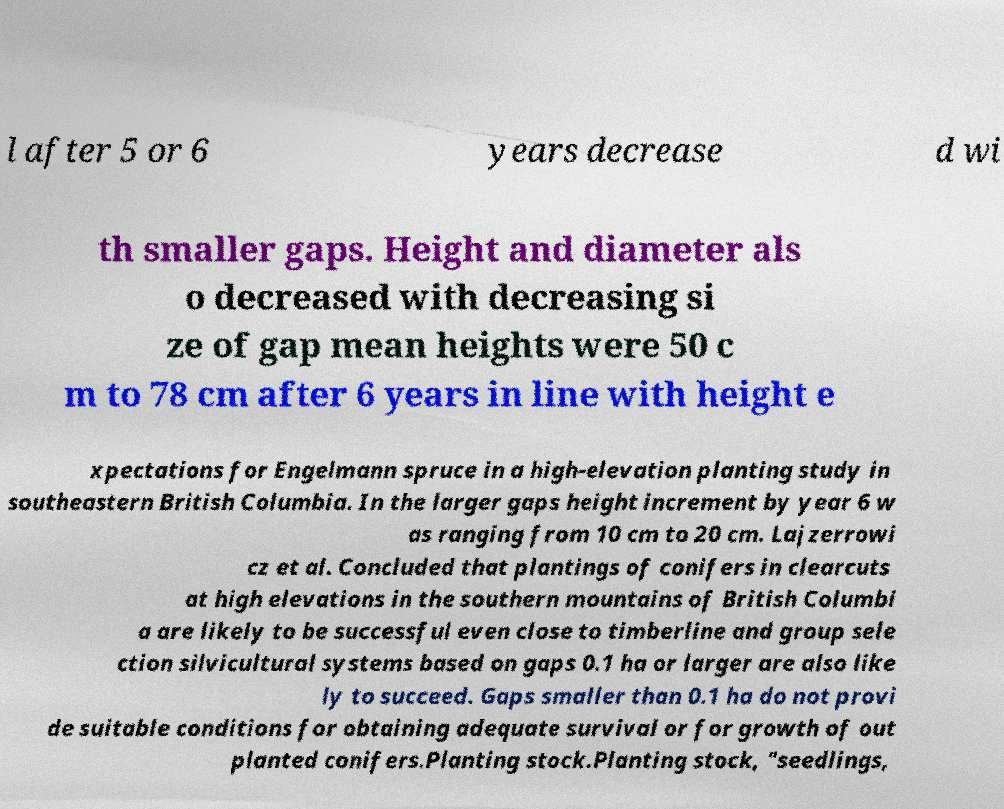Can you read and provide the text displayed in the image?This photo seems to have some interesting text. Can you extract and type it out for me? l after 5 or 6 years decrease d wi th smaller gaps. Height and diameter als o decreased with decreasing si ze of gap mean heights were 50 c m to 78 cm after 6 years in line with height e xpectations for Engelmann spruce in a high-elevation planting study in southeastern British Columbia. In the larger gaps height increment by year 6 w as ranging from 10 cm to 20 cm. Lajzerrowi cz et al. Concluded that plantings of conifers in clearcuts at high elevations in the southern mountains of British Columbi a are likely to be successful even close to timberline and group sele ction silvicultural systems based on gaps 0.1 ha or larger are also like ly to succeed. Gaps smaller than 0.1 ha do not provi de suitable conditions for obtaining adequate survival or for growth of out planted conifers.Planting stock.Planting stock, "seedlings, 